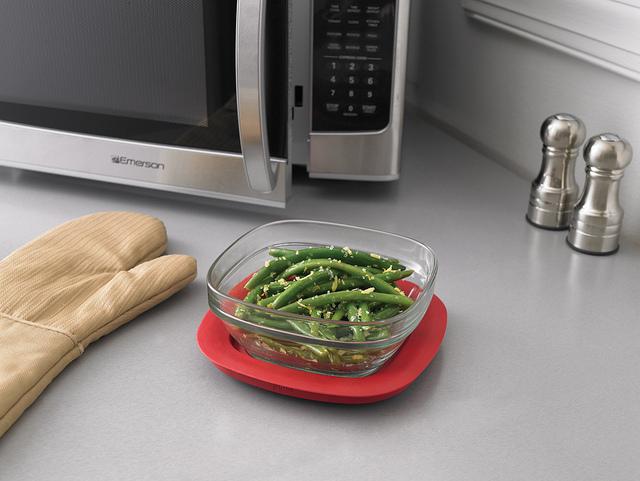How many green veggies are in the bowl?
Be succinct. 1. What is the bowl of green beans sitting on?
Concise answer only. Lid. What is the red item under the bowl?
Concise answer only. Lid. 